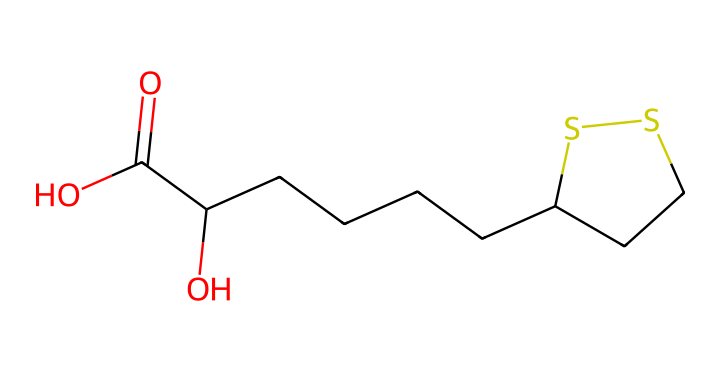What is the main functional group present in alpha-lipoic acid? The main functional group is the carboxylic acid group, identifiable by the -COOH at one end of the molecule.
Answer: carboxylic acid How many carbon atoms are in alpha-lipoic acid? By counting the carbon atoms in the SMILES structure, we see there are 10 carbon atoms present throughout the chain and the functional group.
Answer: 10 What does the presence of sulfur atoms suggest about the properties of alpha-lipoic acid? The presence of sulfur atoms indicates the antioxidant capacity of the molecule, as sulfur can participate in redox reactions, aiding in neutralizing free radicals.
Answer: antioxidant What type of chemical structure does alpha-lipoic acid represent? Alpha-lipoic acid has a bicyclic structure due to the presence of the ring formed by the two sulfur atoms connecting the carbon chains.
Answer: bicyclic Which elements are involved in the backbone of the alpha-lipoic acid molecule? The backbone consists of carbon (C), oxygen (O), and sulfur (S) atoms, which are connected via covalent bonds.
Answer: carbon, oxygen, sulfur What is the total number of  bonds found in alpha-lipoic acid? By analyzing the SMILES representation closely, we can determine that there are 18 bonds connecting the various atoms in the compound, both single and double bonds considered.
Answer: 18 